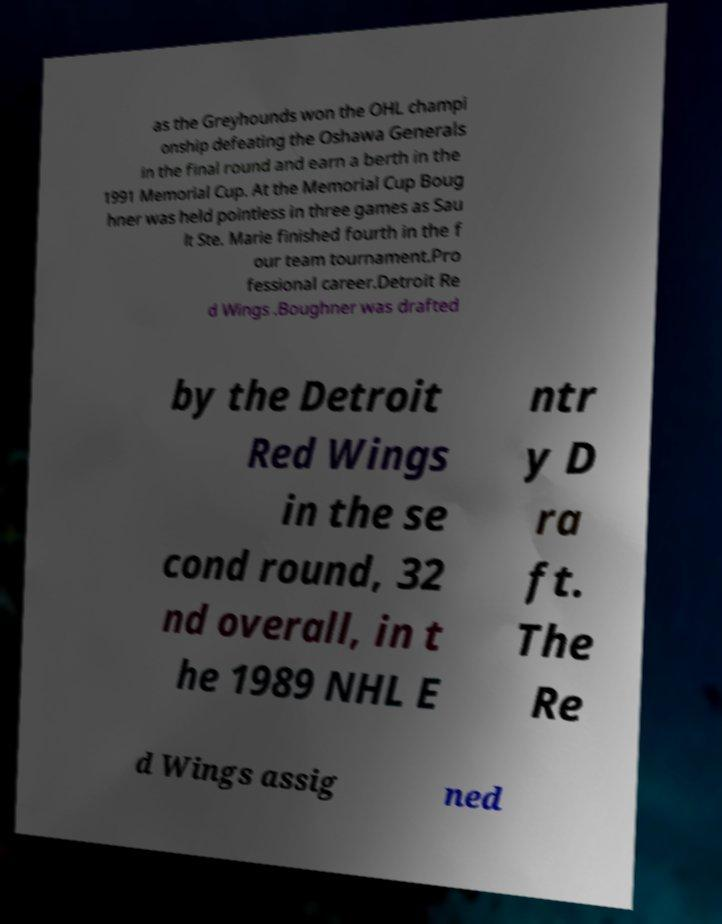For documentation purposes, I need the text within this image transcribed. Could you provide that? as the Greyhounds won the OHL champi onship defeating the Oshawa Generals in the final round and earn a berth in the 1991 Memorial Cup. At the Memorial Cup Boug hner was held pointless in three games as Sau lt Ste. Marie finished fourth in the f our team tournament.Pro fessional career.Detroit Re d Wings .Boughner was drafted by the Detroit Red Wings in the se cond round, 32 nd overall, in t he 1989 NHL E ntr y D ra ft. The Re d Wings assig ned 